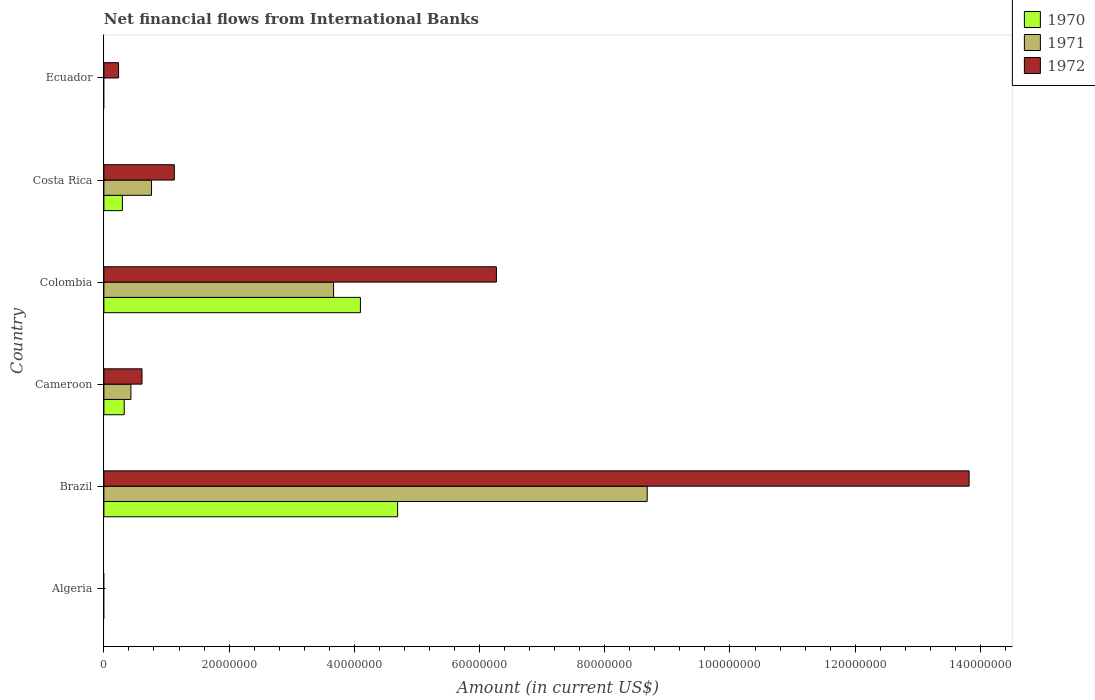How many different coloured bars are there?
Your answer should be compact. 3. Are the number of bars per tick equal to the number of legend labels?
Your answer should be compact. No. How many bars are there on the 6th tick from the top?
Give a very brief answer. 0. In how many cases, is the number of bars for a given country not equal to the number of legend labels?
Offer a terse response. 2. What is the net financial aid flows in 1970 in Costa Rica?
Keep it short and to the point. 2.95e+06. Across all countries, what is the maximum net financial aid flows in 1971?
Make the answer very short. 8.68e+07. In which country was the net financial aid flows in 1972 maximum?
Keep it short and to the point. Brazil. What is the total net financial aid flows in 1972 in the graph?
Offer a very short reply. 2.21e+08. What is the difference between the net financial aid flows in 1972 in Cameroon and that in Costa Rica?
Your response must be concise. -5.17e+06. What is the difference between the net financial aid flows in 1972 in Ecuador and the net financial aid flows in 1970 in Colombia?
Your answer should be very brief. -3.86e+07. What is the average net financial aid flows in 1972 per country?
Your response must be concise. 3.68e+07. What is the difference between the net financial aid flows in 1972 and net financial aid flows in 1970 in Colombia?
Offer a terse response. 2.17e+07. What is the ratio of the net financial aid flows in 1971 in Cameroon to that in Colombia?
Keep it short and to the point. 0.12. Is the net financial aid flows in 1972 in Cameroon less than that in Costa Rica?
Provide a short and direct response. Yes. What is the difference between the highest and the second highest net financial aid flows in 1970?
Provide a succinct answer. 5.94e+06. What is the difference between the highest and the lowest net financial aid flows in 1971?
Ensure brevity in your answer.  8.68e+07. In how many countries, is the net financial aid flows in 1972 greater than the average net financial aid flows in 1972 taken over all countries?
Provide a succinct answer. 2. Is the sum of the net financial aid flows in 1971 in Colombia and Costa Rica greater than the maximum net financial aid flows in 1970 across all countries?
Provide a short and direct response. No. Is it the case that in every country, the sum of the net financial aid flows in 1972 and net financial aid flows in 1970 is greater than the net financial aid flows in 1971?
Give a very brief answer. No. Where does the legend appear in the graph?
Your response must be concise. Top right. How many legend labels are there?
Provide a short and direct response. 3. How are the legend labels stacked?
Offer a terse response. Vertical. What is the title of the graph?
Your answer should be very brief. Net financial flows from International Banks. Does "1995" appear as one of the legend labels in the graph?
Your response must be concise. No. What is the label or title of the X-axis?
Make the answer very short. Amount (in current US$). What is the label or title of the Y-axis?
Your answer should be very brief. Country. What is the Amount (in current US$) in 1970 in Algeria?
Your response must be concise. 0. What is the Amount (in current US$) in 1971 in Algeria?
Make the answer very short. 0. What is the Amount (in current US$) in 1972 in Algeria?
Provide a short and direct response. 0. What is the Amount (in current US$) of 1970 in Brazil?
Offer a very short reply. 4.69e+07. What is the Amount (in current US$) in 1971 in Brazil?
Your response must be concise. 8.68e+07. What is the Amount (in current US$) in 1972 in Brazil?
Give a very brief answer. 1.38e+08. What is the Amount (in current US$) in 1970 in Cameroon?
Offer a very short reply. 3.25e+06. What is the Amount (in current US$) of 1971 in Cameroon?
Ensure brevity in your answer.  4.32e+06. What is the Amount (in current US$) in 1972 in Cameroon?
Provide a short and direct response. 6.09e+06. What is the Amount (in current US$) in 1970 in Colombia?
Your answer should be compact. 4.10e+07. What is the Amount (in current US$) of 1971 in Colombia?
Give a very brief answer. 3.67e+07. What is the Amount (in current US$) of 1972 in Colombia?
Your response must be concise. 6.27e+07. What is the Amount (in current US$) of 1970 in Costa Rica?
Make the answer very short. 2.95e+06. What is the Amount (in current US$) of 1971 in Costa Rica?
Keep it short and to the point. 7.61e+06. What is the Amount (in current US$) in 1972 in Costa Rica?
Ensure brevity in your answer.  1.13e+07. What is the Amount (in current US$) of 1972 in Ecuador?
Your answer should be compact. 2.34e+06. Across all countries, what is the maximum Amount (in current US$) in 1970?
Offer a terse response. 4.69e+07. Across all countries, what is the maximum Amount (in current US$) of 1971?
Ensure brevity in your answer.  8.68e+07. Across all countries, what is the maximum Amount (in current US$) in 1972?
Ensure brevity in your answer.  1.38e+08. Across all countries, what is the minimum Amount (in current US$) of 1972?
Your response must be concise. 0. What is the total Amount (in current US$) in 1970 in the graph?
Your answer should be compact. 9.41e+07. What is the total Amount (in current US$) of 1971 in the graph?
Keep it short and to the point. 1.35e+08. What is the total Amount (in current US$) of 1972 in the graph?
Your answer should be very brief. 2.21e+08. What is the difference between the Amount (in current US$) in 1970 in Brazil and that in Cameroon?
Give a very brief answer. 4.37e+07. What is the difference between the Amount (in current US$) in 1971 in Brazil and that in Cameroon?
Give a very brief answer. 8.25e+07. What is the difference between the Amount (in current US$) of 1972 in Brazil and that in Cameroon?
Your answer should be compact. 1.32e+08. What is the difference between the Amount (in current US$) of 1970 in Brazil and that in Colombia?
Offer a terse response. 5.94e+06. What is the difference between the Amount (in current US$) of 1971 in Brazil and that in Colombia?
Provide a succinct answer. 5.01e+07. What is the difference between the Amount (in current US$) in 1972 in Brazil and that in Colombia?
Make the answer very short. 7.55e+07. What is the difference between the Amount (in current US$) in 1970 in Brazil and that in Costa Rica?
Provide a short and direct response. 4.40e+07. What is the difference between the Amount (in current US$) of 1971 in Brazil and that in Costa Rica?
Offer a terse response. 7.92e+07. What is the difference between the Amount (in current US$) of 1972 in Brazil and that in Costa Rica?
Offer a terse response. 1.27e+08. What is the difference between the Amount (in current US$) of 1972 in Brazil and that in Ecuador?
Make the answer very short. 1.36e+08. What is the difference between the Amount (in current US$) of 1970 in Cameroon and that in Colombia?
Provide a short and direct response. -3.77e+07. What is the difference between the Amount (in current US$) of 1971 in Cameroon and that in Colombia?
Your answer should be compact. -3.24e+07. What is the difference between the Amount (in current US$) of 1972 in Cameroon and that in Colombia?
Keep it short and to the point. -5.66e+07. What is the difference between the Amount (in current US$) of 1970 in Cameroon and that in Costa Rica?
Your response must be concise. 2.98e+05. What is the difference between the Amount (in current US$) of 1971 in Cameroon and that in Costa Rica?
Ensure brevity in your answer.  -3.29e+06. What is the difference between the Amount (in current US$) in 1972 in Cameroon and that in Costa Rica?
Provide a short and direct response. -5.17e+06. What is the difference between the Amount (in current US$) of 1972 in Cameroon and that in Ecuador?
Offer a terse response. 3.74e+06. What is the difference between the Amount (in current US$) in 1970 in Colombia and that in Costa Rica?
Your response must be concise. 3.80e+07. What is the difference between the Amount (in current US$) of 1971 in Colombia and that in Costa Rica?
Your answer should be compact. 2.91e+07. What is the difference between the Amount (in current US$) of 1972 in Colombia and that in Costa Rica?
Provide a short and direct response. 5.14e+07. What is the difference between the Amount (in current US$) of 1972 in Colombia and that in Ecuador?
Your response must be concise. 6.04e+07. What is the difference between the Amount (in current US$) in 1972 in Costa Rica and that in Ecuador?
Ensure brevity in your answer.  8.91e+06. What is the difference between the Amount (in current US$) of 1970 in Brazil and the Amount (in current US$) of 1971 in Cameroon?
Your response must be concise. 4.26e+07. What is the difference between the Amount (in current US$) in 1970 in Brazil and the Amount (in current US$) in 1972 in Cameroon?
Your answer should be compact. 4.08e+07. What is the difference between the Amount (in current US$) of 1971 in Brazil and the Amount (in current US$) of 1972 in Cameroon?
Your answer should be very brief. 8.07e+07. What is the difference between the Amount (in current US$) of 1970 in Brazil and the Amount (in current US$) of 1971 in Colombia?
Keep it short and to the point. 1.02e+07. What is the difference between the Amount (in current US$) of 1970 in Brazil and the Amount (in current US$) of 1972 in Colombia?
Offer a terse response. -1.58e+07. What is the difference between the Amount (in current US$) of 1971 in Brazil and the Amount (in current US$) of 1972 in Colombia?
Your answer should be compact. 2.41e+07. What is the difference between the Amount (in current US$) of 1970 in Brazil and the Amount (in current US$) of 1971 in Costa Rica?
Give a very brief answer. 3.93e+07. What is the difference between the Amount (in current US$) in 1970 in Brazil and the Amount (in current US$) in 1972 in Costa Rica?
Provide a succinct answer. 3.57e+07. What is the difference between the Amount (in current US$) in 1971 in Brazil and the Amount (in current US$) in 1972 in Costa Rica?
Give a very brief answer. 7.55e+07. What is the difference between the Amount (in current US$) of 1970 in Brazil and the Amount (in current US$) of 1972 in Ecuador?
Your answer should be very brief. 4.46e+07. What is the difference between the Amount (in current US$) of 1971 in Brazil and the Amount (in current US$) of 1972 in Ecuador?
Your answer should be compact. 8.44e+07. What is the difference between the Amount (in current US$) of 1970 in Cameroon and the Amount (in current US$) of 1971 in Colombia?
Offer a terse response. -3.34e+07. What is the difference between the Amount (in current US$) of 1970 in Cameroon and the Amount (in current US$) of 1972 in Colombia?
Offer a very short reply. -5.94e+07. What is the difference between the Amount (in current US$) in 1971 in Cameroon and the Amount (in current US$) in 1972 in Colombia?
Provide a succinct answer. -5.84e+07. What is the difference between the Amount (in current US$) in 1970 in Cameroon and the Amount (in current US$) in 1971 in Costa Rica?
Provide a succinct answer. -4.36e+06. What is the difference between the Amount (in current US$) in 1970 in Cameroon and the Amount (in current US$) in 1972 in Costa Rica?
Your response must be concise. -8.00e+06. What is the difference between the Amount (in current US$) in 1971 in Cameroon and the Amount (in current US$) in 1972 in Costa Rica?
Give a very brief answer. -6.94e+06. What is the difference between the Amount (in current US$) of 1970 in Cameroon and the Amount (in current US$) of 1972 in Ecuador?
Keep it short and to the point. 9.08e+05. What is the difference between the Amount (in current US$) of 1971 in Cameroon and the Amount (in current US$) of 1972 in Ecuador?
Make the answer very short. 1.98e+06. What is the difference between the Amount (in current US$) in 1970 in Colombia and the Amount (in current US$) in 1971 in Costa Rica?
Offer a terse response. 3.34e+07. What is the difference between the Amount (in current US$) of 1970 in Colombia and the Amount (in current US$) of 1972 in Costa Rica?
Provide a succinct answer. 2.97e+07. What is the difference between the Amount (in current US$) of 1971 in Colombia and the Amount (in current US$) of 1972 in Costa Rica?
Make the answer very short. 2.54e+07. What is the difference between the Amount (in current US$) in 1970 in Colombia and the Amount (in current US$) in 1972 in Ecuador?
Give a very brief answer. 3.86e+07. What is the difference between the Amount (in current US$) of 1971 in Colombia and the Amount (in current US$) of 1972 in Ecuador?
Offer a terse response. 3.43e+07. What is the difference between the Amount (in current US$) of 1970 in Costa Rica and the Amount (in current US$) of 1972 in Ecuador?
Your answer should be very brief. 6.10e+05. What is the difference between the Amount (in current US$) in 1971 in Costa Rica and the Amount (in current US$) in 1972 in Ecuador?
Your answer should be very brief. 5.27e+06. What is the average Amount (in current US$) in 1970 per country?
Offer a terse response. 1.57e+07. What is the average Amount (in current US$) of 1971 per country?
Give a very brief answer. 2.26e+07. What is the average Amount (in current US$) in 1972 per country?
Offer a very short reply. 3.68e+07. What is the difference between the Amount (in current US$) in 1970 and Amount (in current US$) in 1971 in Brazil?
Ensure brevity in your answer.  -3.99e+07. What is the difference between the Amount (in current US$) in 1970 and Amount (in current US$) in 1972 in Brazil?
Keep it short and to the point. -9.13e+07. What is the difference between the Amount (in current US$) of 1971 and Amount (in current US$) of 1972 in Brazil?
Offer a very short reply. -5.14e+07. What is the difference between the Amount (in current US$) of 1970 and Amount (in current US$) of 1971 in Cameroon?
Give a very brief answer. -1.07e+06. What is the difference between the Amount (in current US$) in 1970 and Amount (in current US$) in 1972 in Cameroon?
Your answer should be compact. -2.84e+06. What is the difference between the Amount (in current US$) of 1971 and Amount (in current US$) of 1972 in Cameroon?
Offer a very short reply. -1.77e+06. What is the difference between the Amount (in current US$) of 1970 and Amount (in current US$) of 1971 in Colombia?
Provide a short and direct response. 4.29e+06. What is the difference between the Amount (in current US$) of 1970 and Amount (in current US$) of 1972 in Colombia?
Your answer should be compact. -2.17e+07. What is the difference between the Amount (in current US$) in 1971 and Amount (in current US$) in 1972 in Colombia?
Provide a succinct answer. -2.60e+07. What is the difference between the Amount (in current US$) in 1970 and Amount (in current US$) in 1971 in Costa Rica?
Your response must be concise. -4.66e+06. What is the difference between the Amount (in current US$) in 1970 and Amount (in current US$) in 1972 in Costa Rica?
Your response must be concise. -8.30e+06. What is the difference between the Amount (in current US$) of 1971 and Amount (in current US$) of 1972 in Costa Rica?
Your response must be concise. -3.64e+06. What is the ratio of the Amount (in current US$) in 1970 in Brazil to that in Cameroon?
Your answer should be very brief. 14.44. What is the ratio of the Amount (in current US$) of 1971 in Brazil to that in Cameroon?
Offer a terse response. 20.1. What is the ratio of the Amount (in current US$) in 1972 in Brazil to that in Cameroon?
Ensure brevity in your answer.  22.7. What is the ratio of the Amount (in current US$) of 1970 in Brazil to that in Colombia?
Your answer should be very brief. 1.15. What is the ratio of the Amount (in current US$) of 1971 in Brazil to that in Colombia?
Your response must be concise. 2.37. What is the ratio of the Amount (in current US$) in 1972 in Brazil to that in Colombia?
Ensure brevity in your answer.  2.2. What is the ratio of the Amount (in current US$) in 1970 in Brazil to that in Costa Rica?
Offer a terse response. 15.89. What is the ratio of the Amount (in current US$) of 1971 in Brazil to that in Costa Rica?
Keep it short and to the point. 11.41. What is the ratio of the Amount (in current US$) of 1972 in Brazil to that in Costa Rica?
Keep it short and to the point. 12.28. What is the ratio of the Amount (in current US$) of 1972 in Brazil to that in Ecuador?
Provide a succinct answer. 59.01. What is the ratio of the Amount (in current US$) in 1970 in Cameroon to that in Colombia?
Ensure brevity in your answer.  0.08. What is the ratio of the Amount (in current US$) of 1971 in Cameroon to that in Colombia?
Your answer should be very brief. 0.12. What is the ratio of the Amount (in current US$) in 1972 in Cameroon to that in Colombia?
Your answer should be compact. 0.1. What is the ratio of the Amount (in current US$) of 1970 in Cameroon to that in Costa Rica?
Offer a terse response. 1.1. What is the ratio of the Amount (in current US$) in 1971 in Cameroon to that in Costa Rica?
Offer a very short reply. 0.57. What is the ratio of the Amount (in current US$) of 1972 in Cameroon to that in Costa Rica?
Keep it short and to the point. 0.54. What is the ratio of the Amount (in current US$) in 1972 in Cameroon to that in Ecuador?
Offer a terse response. 2.6. What is the ratio of the Amount (in current US$) of 1970 in Colombia to that in Costa Rica?
Provide a short and direct response. 13.88. What is the ratio of the Amount (in current US$) in 1971 in Colombia to that in Costa Rica?
Keep it short and to the point. 4.82. What is the ratio of the Amount (in current US$) of 1972 in Colombia to that in Costa Rica?
Offer a very short reply. 5.57. What is the ratio of the Amount (in current US$) of 1972 in Colombia to that in Ecuador?
Your answer should be very brief. 26.77. What is the ratio of the Amount (in current US$) of 1972 in Costa Rica to that in Ecuador?
Your answer should be compact. 4.8. What is the difference between the highest and the second highest Amount (in current US$) of 1970?
Offer a very short reply. 5.94e+06. What is the difference between the highest and the second highest Amount (in current US$) of 1971?
Provide a short and direct response. 5.01e+07. What is the difference between the highest and the second highest Amount (in current US$) of 1972?
Make the answer very short. 7.55e+07. What is the difference between the highest and the lowest Amount (in current US$) in 1970?
Your response must be concise. 4.69e+07. What is the difference between the highest and the lowest Amount (in current US$) in 1971?
Provide a short and direct response. 8.68e+07. What is the difference between the highest and the lowest Amount (in current US$) of 1972?
Your answer should be very brief. 1.38e+08. 